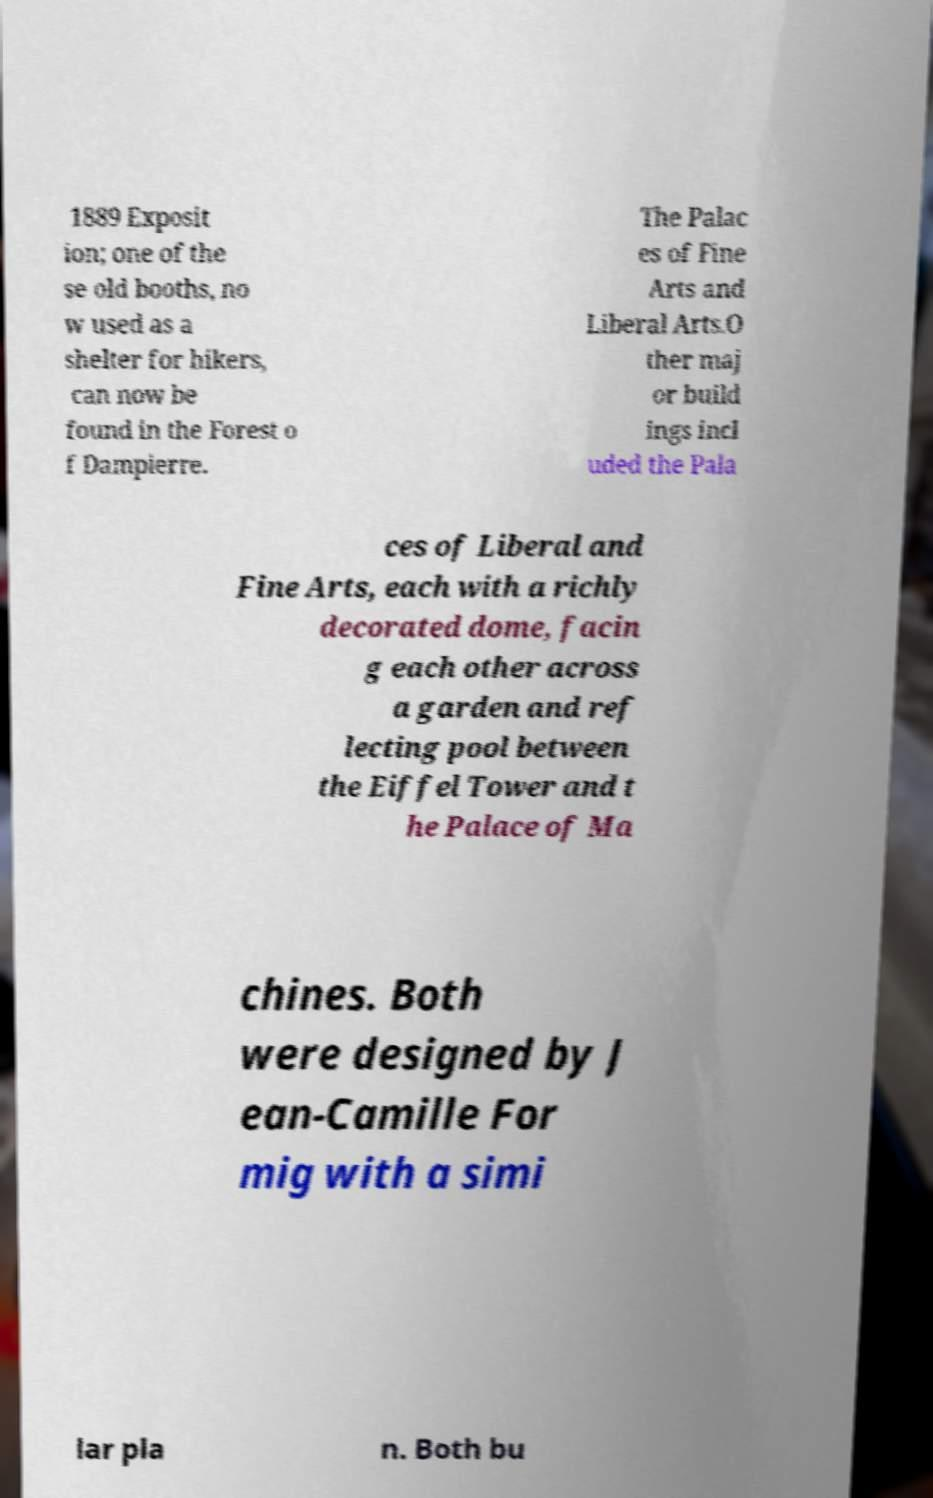Could you assist in decoding the text presented in this image and type it out clearly? 1889 Exposit ion; one of the se old booths, no w used as a shelter for hikers, can now be found in the Forest o f Dampierre. The Palac es of Fine Arts and Liberal Arts.O ther maj or build ings incl uded the Pala ces of Liberal and Fine Arts, each with a richly decorated dome, facin g each other across a garden and ref lecting pool between the Eiffel Tower and t he Palace of Ma chines. Both were designed by J ean-Camille For mig with a simi lar pla n. Both bu 